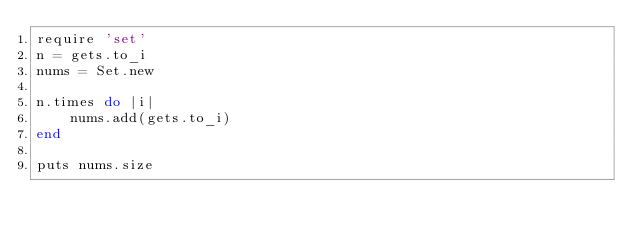Convert code to text. <code><loc_0><loc_0><loc_500><loc_500><_Ruby_>require 'set'
n = gets.to_i
nums = Set.new

n.times do |i|
    nums.add(gets.to_i)
end

puts nums.size
</code> 